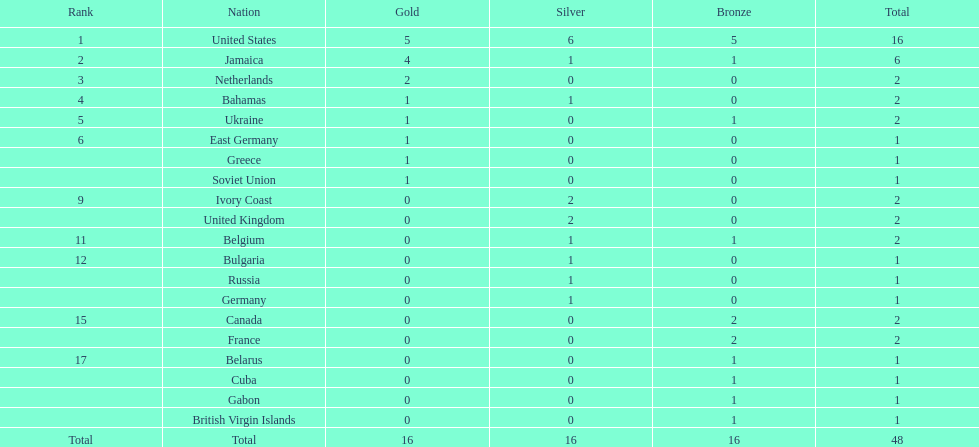How many gold medals did the us and jamaica win combined? 9. 